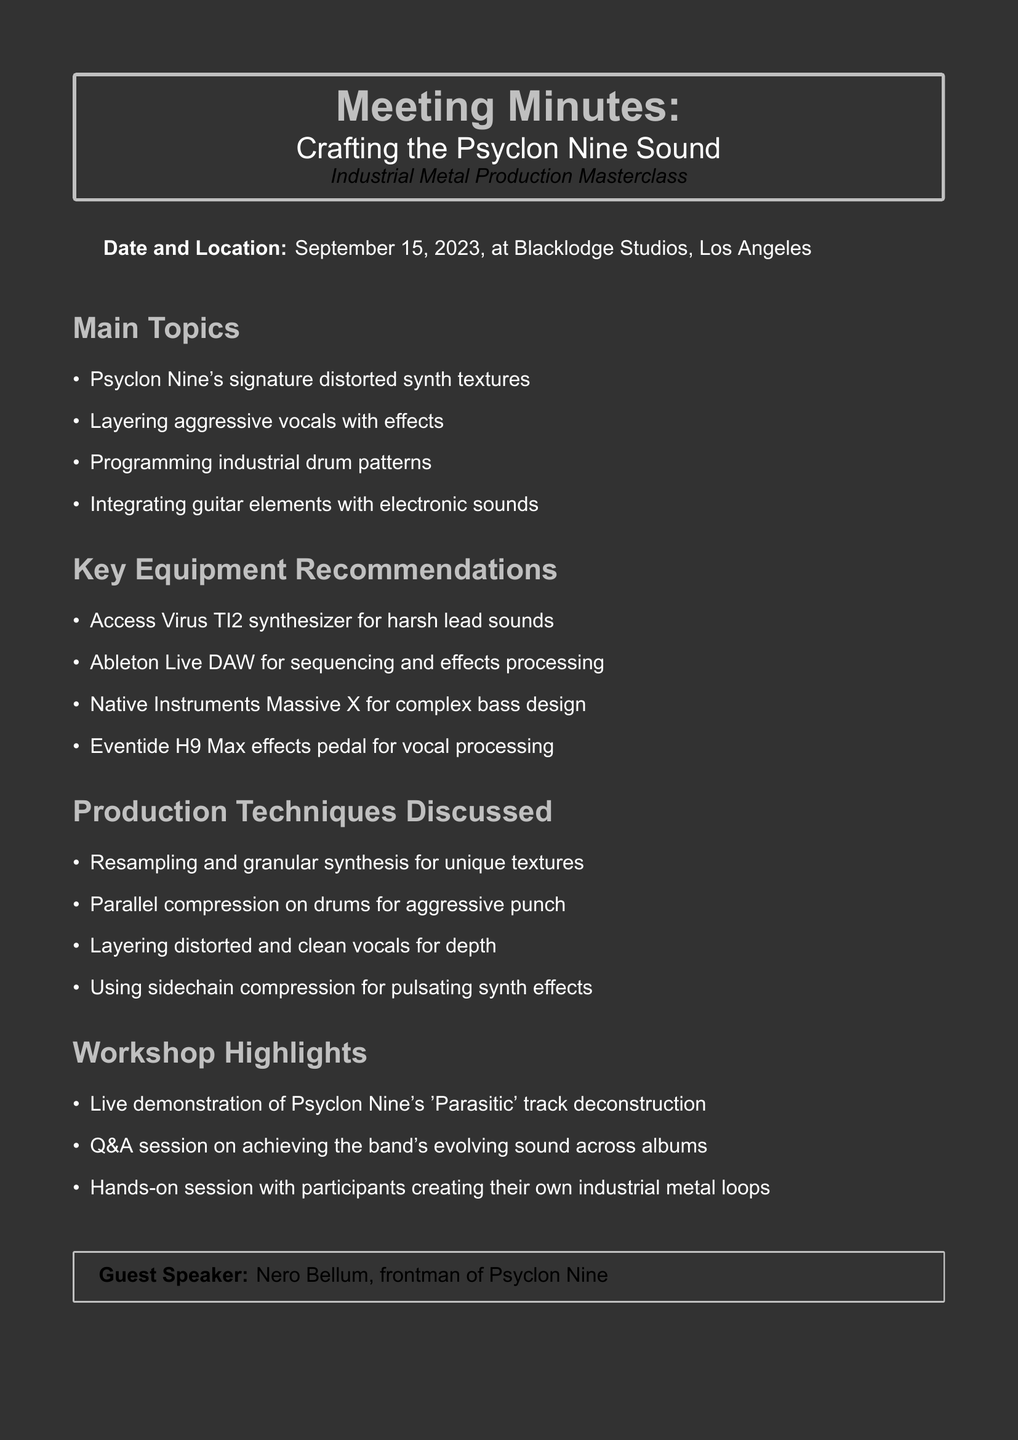What is the date of the workshop? The date of the workshop is explicitly mentioned in the document as September 15, 2023.
Answer: September 15, 2023 Where was the workshop held? The location of the workshop is specified in the document as Blacklodge Studios, Los Angeles.
Answer: Blacklodge Studios, Los Angeles Who was the guest speaker at the workshop? The guest speaker is mentioned in the document as Nero Bellum, the frontman of Psyclon Nine.
Answer: Nero Bellum Which synthesizer is recommended for harsh lead sounds? The document lists the Access Virus TI2 synthesizer specifically for harsh lead sounds.
Answer: Access Virus TI2 synthesizer What production technique is used for aggressive drum punch? The document mentions parallel compression as a technique for achieving aggressive punch on drums.
Answer: Parallel compression What was one of the highlights of the workshop? The document states that a live demonstration of Psyclon Nine's 'Parasitic' track deconstruction was a highlight.
Answer: Live demonstration of Psyclon Nine's 'Parasitic' track deconstruction What software is recommended for sequencing and effects processing? The document recommends Ableton Live DAW for sequencing and effects processing.
Answer: Ableton Live DAW What takeaway resource was provided for DIY instrument creation? The document lists a PDF guide on DIY instrument creation as one of the takeaway resources.
Answer: PDF guide on DIY instrument creation 